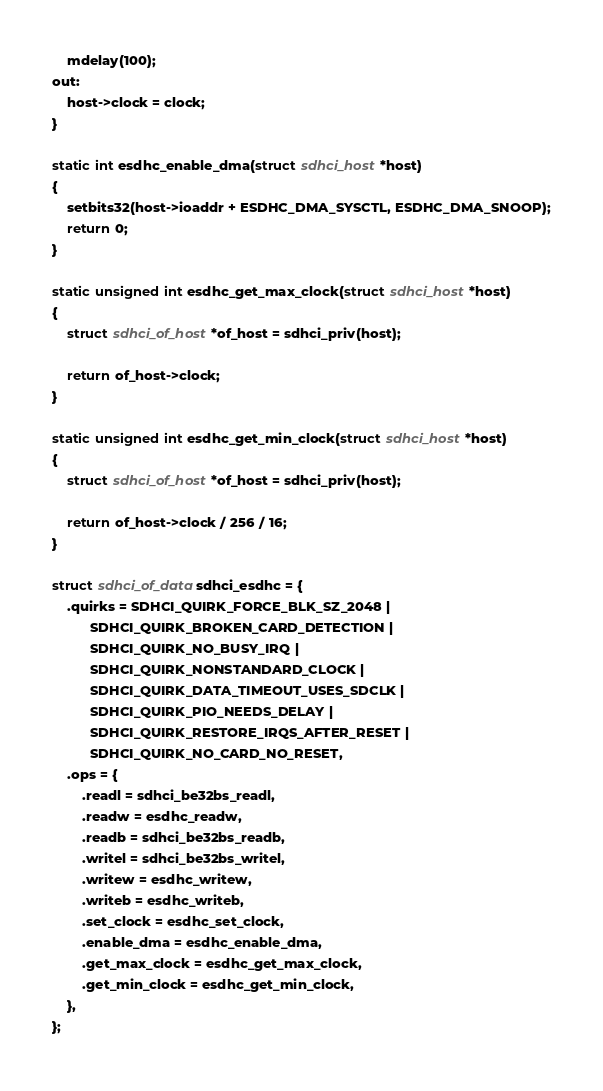<code> <loc_0><loc_0><loc_500><loc_500><_C_>	mdelay(100);
out:
	host->clock = clock;
}

static int esdhc_enable_dma(struct sdhci_host *host)
{
	setbits32(host->ioaddr + ESDHC_DMA_SYSCTL, ESDHC_DMA_SNOOP);
	return 0;
}

static unsigned int esdhc_get_max_clock(struct sdhci_host *host)
{
	struct sdhci_of_host *of_host = sdhci_priv(host);

	return of_host->clock;
}

static unsigned int esdhc_get_min_clock(struct sdhci_host *host)
{
	struct sdhci_of_host *of_host = sdhci_priv(host);

	return of_host->clock / 256 / 16;
}

struct sdhci_of_data sdhci_esdhc = {
	.quirks = SDHCI_QUIRK_FORCE_BLK_SZ_2048 |
		  SDHCI_QUIRK_BROKEN_CARD_DETECTION |
		  SDHCI_QUIRK_NO_BUSY_IRQ |
		  SDHCI_QUIRK_NONSTANDARD_CLOCK |
		  SDHCI_QUIRK_DATA_TIMEOUT_USES_SDCLK |
		  SDHCI_QUIRK_PIO_NEEDS_DELAY |
		  SDHCI_QUIRK_RESTORE_IRQS_AFTER_RESET |
		  SDHCI_QUIRK_NO_CARD_NO_RESET,
	.ops = {
		.readl = sdhci_be32bs_readl,
		.readw = esdhc_readw,
		.readb = sdhci_be32bs_readb,
		.writel = sdhci_be32bs_writel,
		.writew = esdhc_writew,
		.writeb = esdhc_writeb,
		.set_clock = esdhc_set_clock,
		.enable_dma = esdhc_enable_dma,
		.get_max_clock = esdhc_get_max_clock,
		.get_min_clock = esdhc_get_min_clock,
	},
};
</code> 